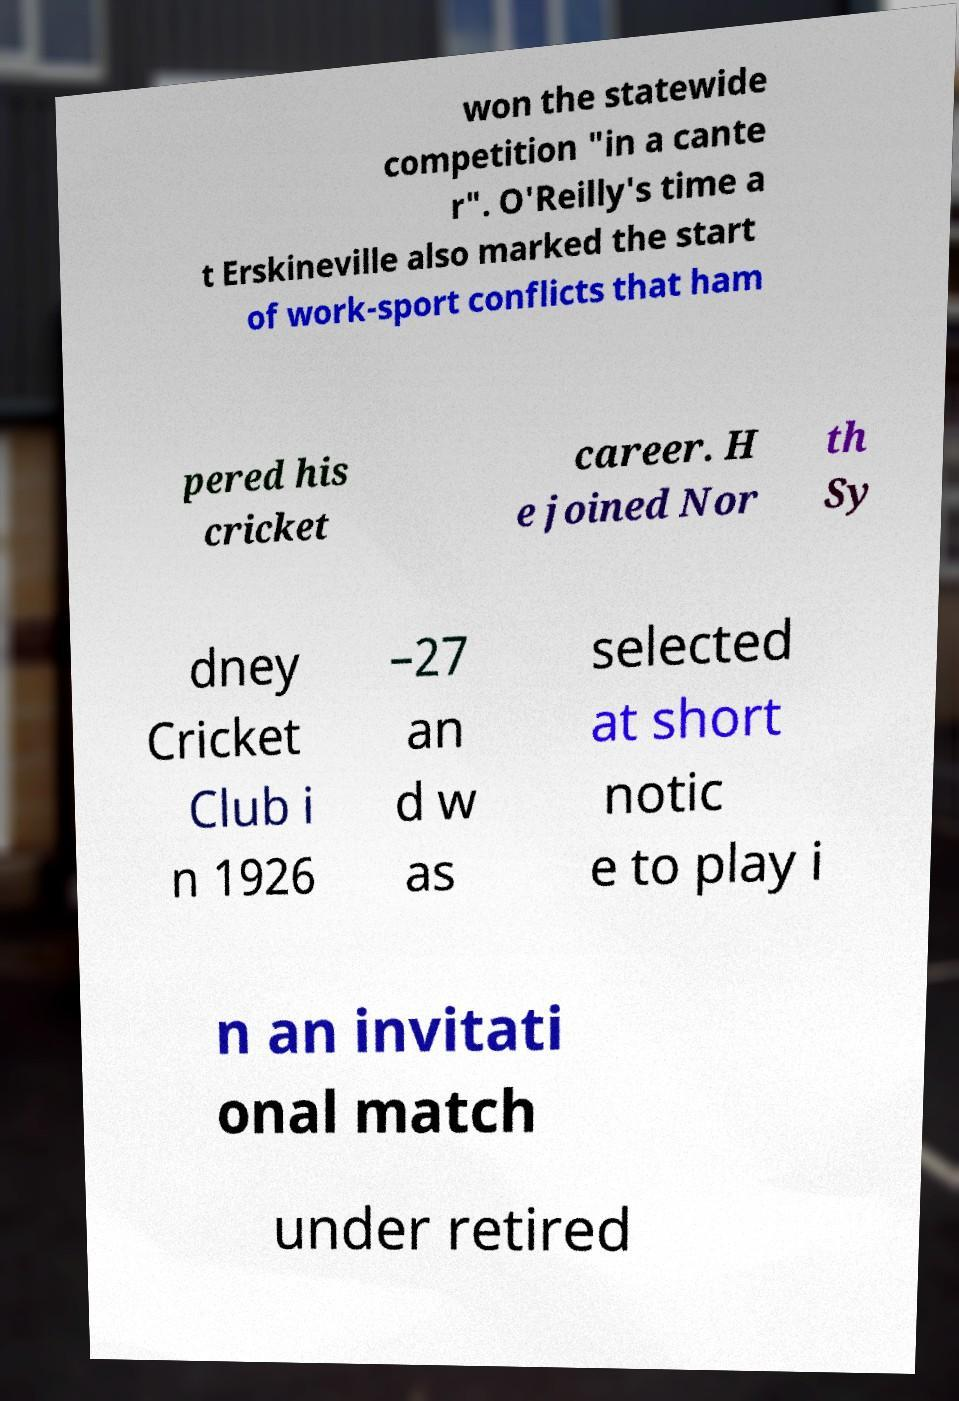Can you accurately transcribe the text from the provided image for me? won the statewide competition "in a cante r". O'Reilly's time a t Erskineville also marked the start of work-sport conflicts that ham pered his cricket career. H e joined Nor th Sy dney Cricket Club i n 1926 –27 an d w as selected at short notic e to play i n an invitati onal match under retired 